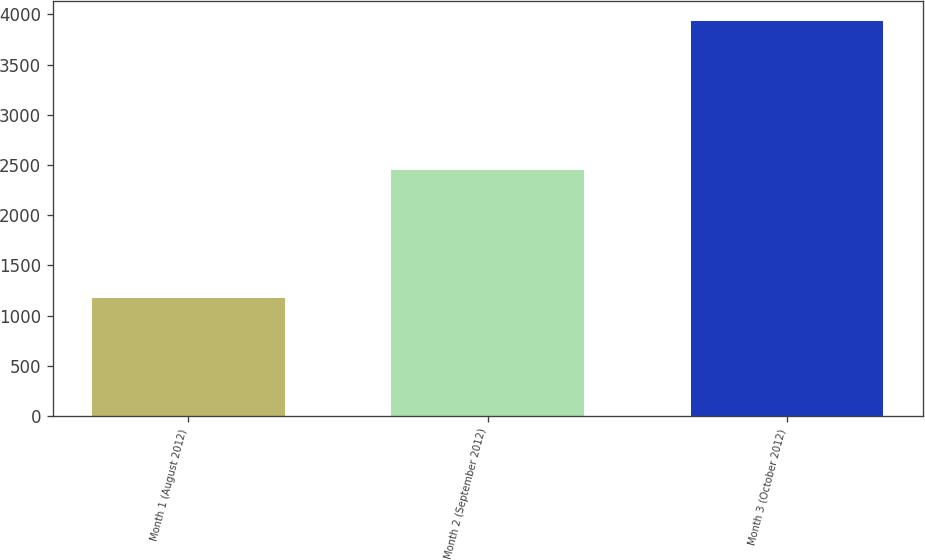Convert chart to OTSL. <chart><loc_0><loc_0><loc_500><loc_500><bar_chart><fcel>Month 1 (August 2012)<fcel>Month 2 (September 2012)<fcel>Month 3 (October 2012)<nl><fcel>1176<fcel>2453<fcel>3933<nl></chart> 